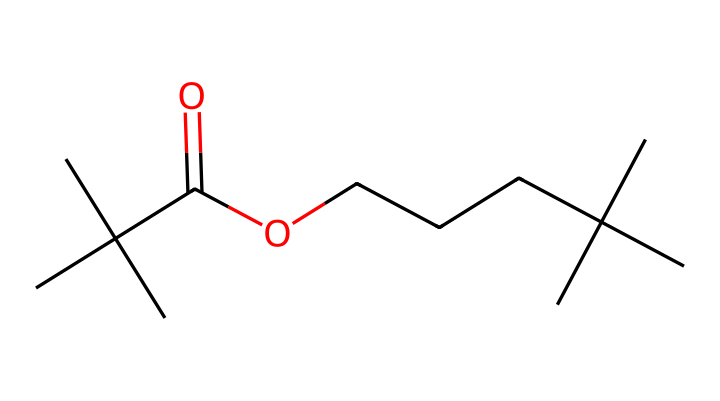What is the main functional group present in this molecule? The molecule contains a carboxylic acid group, which is identified by the presence of the -COOH functional group (C(=O)O).
Answer: carboxylic acid How many carbon atoms are in this molecule? By counting the number of carbon symbols (C) in the SMILES representation, there are 12 carbon atoms in total.
Answer: 12 What type of bonding is primarily exhibited in this molecule? The molecule contains single and double bonds, with the double bond between carbon and oxygen (C=O) and single bonds between carbon atoms and the carboxylic group, which is characteristic of saturated organic compounds.
Answer: single and double bonds Is this chemical likely to be hazardous? Given that it contains a carboxylic acid group and is used in adhesives, it may release volatile organic compounds (VOCs) and irritate skin and eyes, categorizing it as potentially hazardous.
Answer: yes What is the approximate molecular weight of this molecule? To calculate the molecular weight, you sum the atomic weights of all constituent atoms based on the chemical formula, leading to an approximate molecular weight of 198 g/mol.
Answer: 198 g/mol 